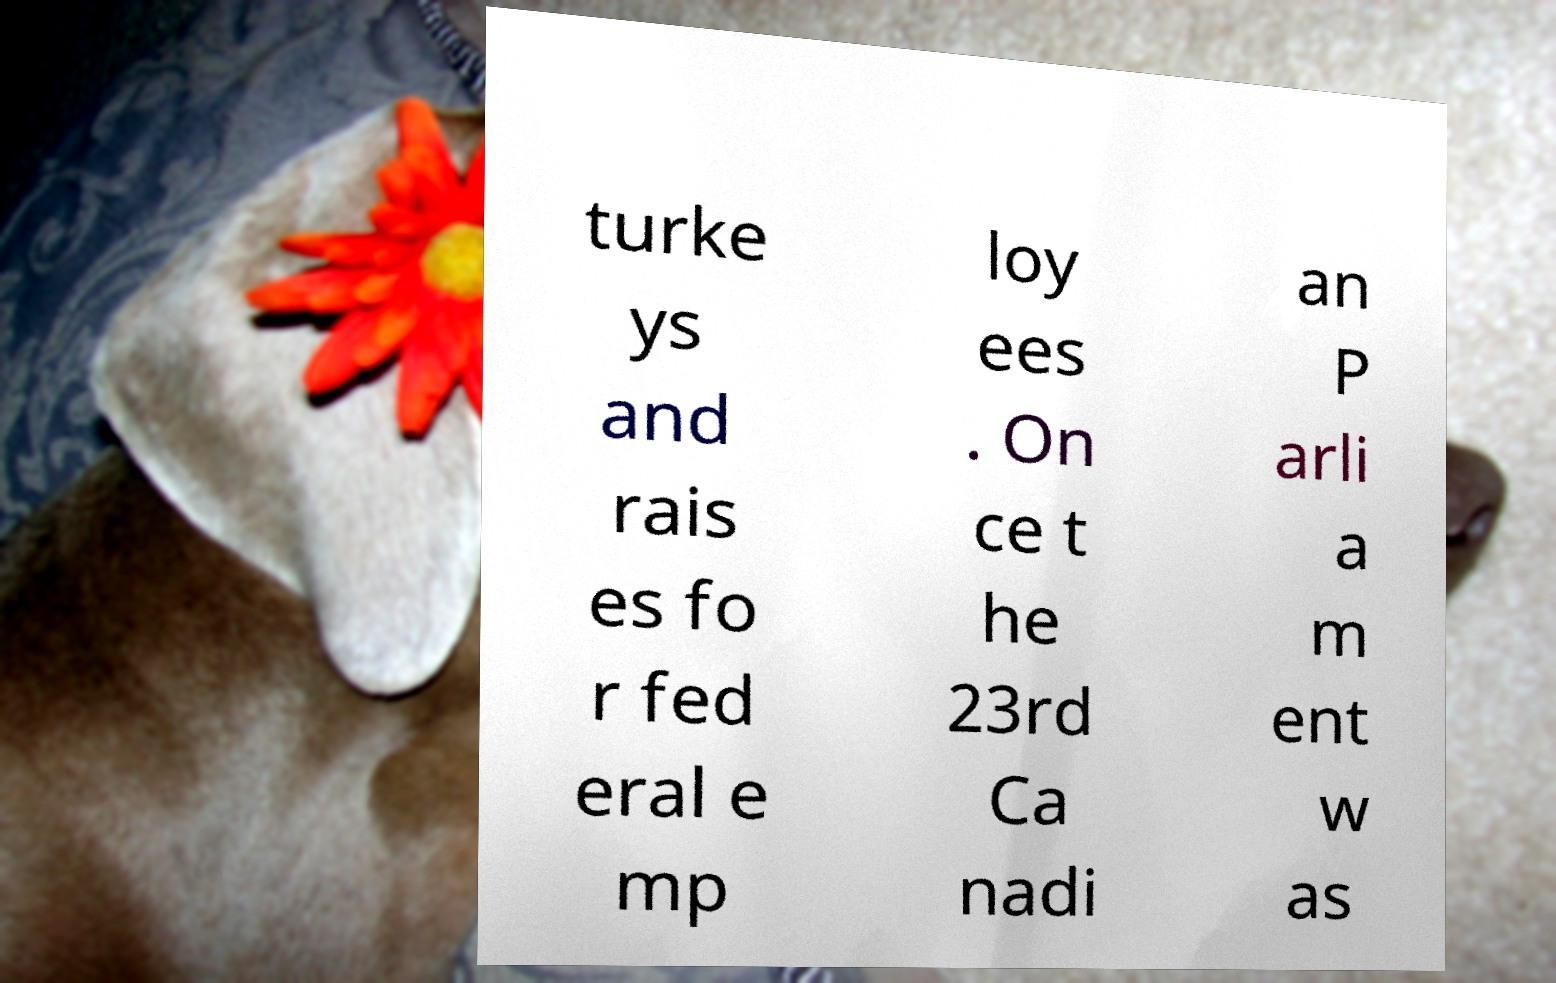There's text embedded in this image that I need extracted. Can you transcribe it verbatim? turke ys and rais es fo r fed eral e mp loy ees . On ce t he 23rd Ca nadi an P arli a m ent w as 